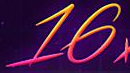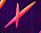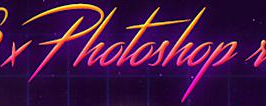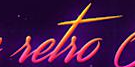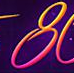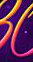Read the text content from these images in order, separated by a semicolon. 16; ×; Photoshop; setso; 8; # 